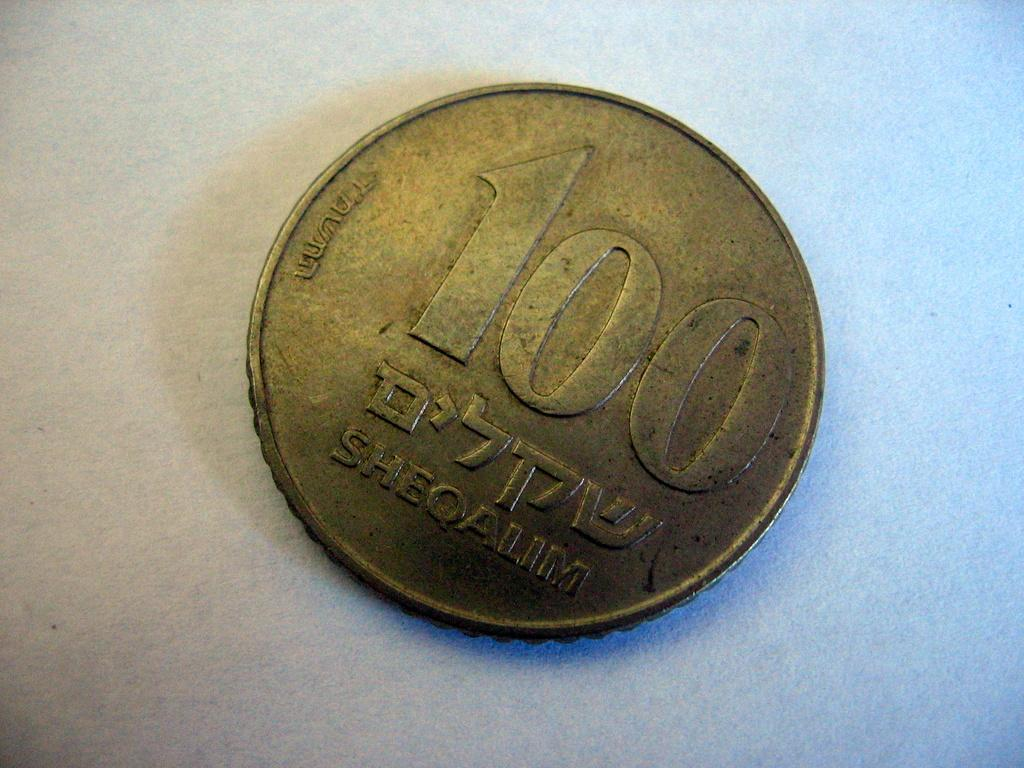<image>
Provide a brief description of the given image. An old, gold Sheqalim coin with the number 100 on it. 